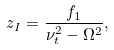<formula> <loc_0><loc_0><loc_500><loc_500>z _ { I } = \frac { f _ { 1 } } { \nu _ { t } ^ { 2 } - \Omega ^ { 2 } } ,</formula> 